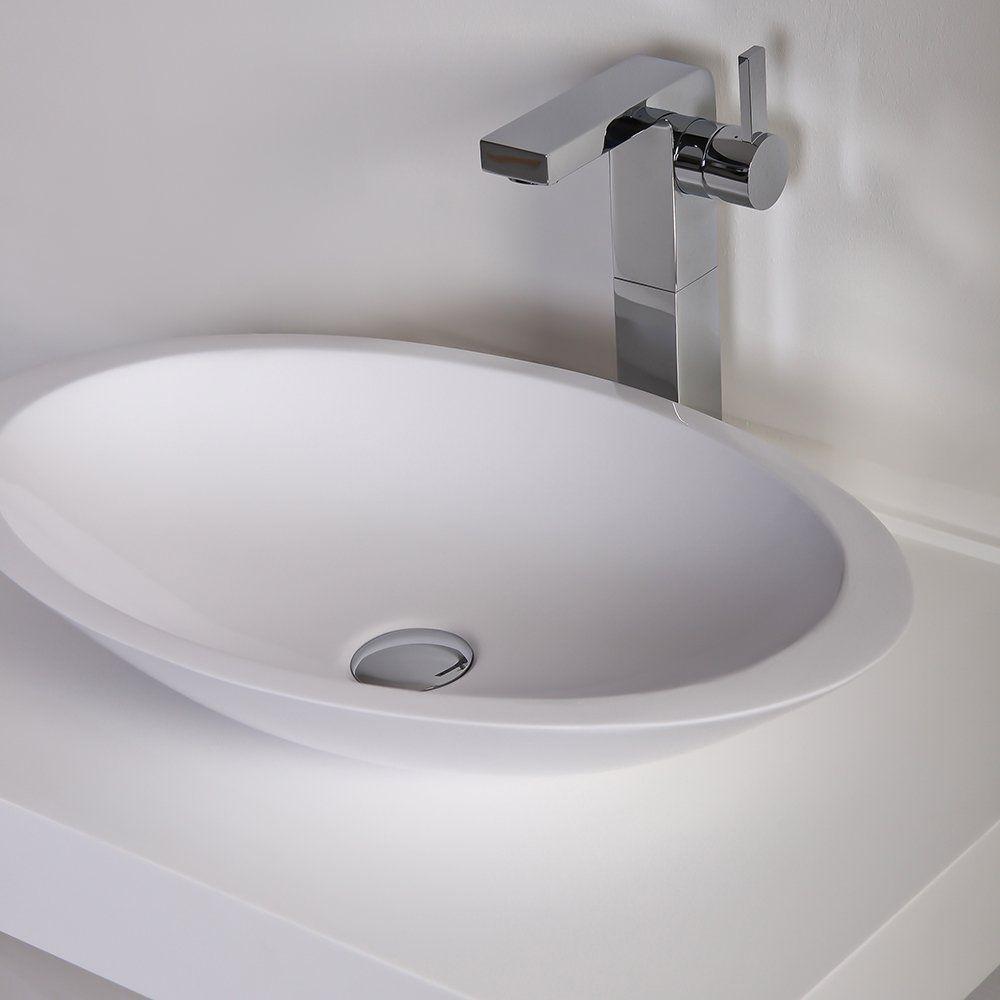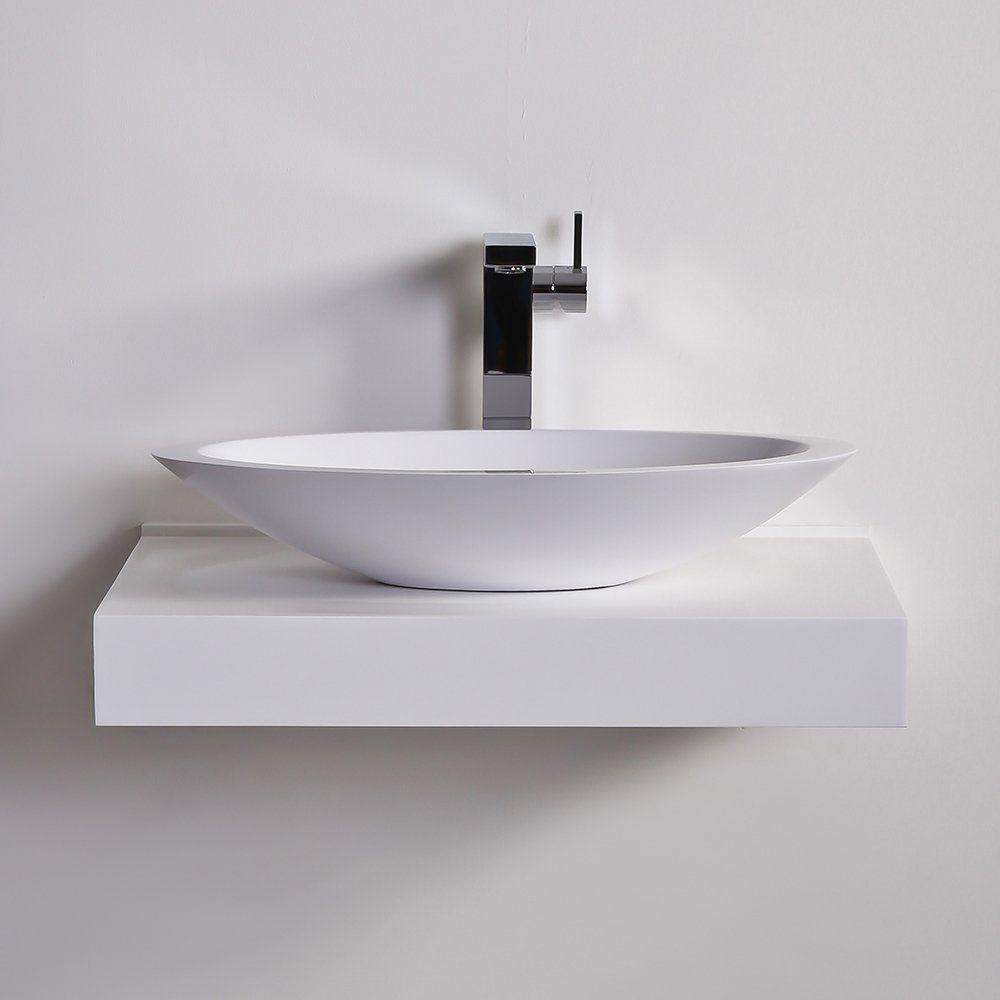The first image is the image on the left, the second image is the image on the right. Considering the images on both sides, is "In one image a sink and a bathroom floor are seen." valid? Answer yes or no. No. The first image is the image on the left, the second image is the image on the right. For the images displayed, is the sentence "Every single sink has a basin in the shape of a bowl." factually correct? Answer yes or no. Yes. The first image is the image on the left, the second image is the image on the right. Examine the images to the left and right. Is the description "There are two basins set in the counter on the right." accurate? Answer yes or no. No. The first image is the image on the left, the second image is the image on the right. Assess this claim about the two images: "One image shows a wall-mounted rectangular counter with two separate sink and faucet features.". Correct or not? Answer yes or no. No. 